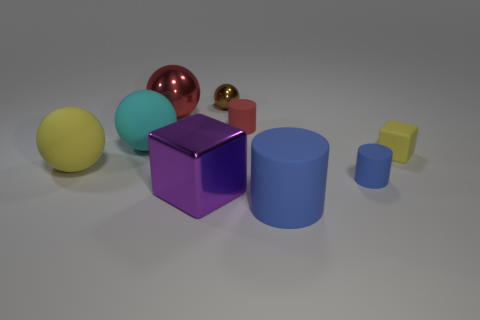Add 1 cyan cylinders. How many objects exist? 10 Subtract all tiny rubber cylinders. How many cylinders are left? 1 Subtract all brown spheres. How many spheres are left? 3 Subtract 1 blocks. How many blocks are left? 1 Subtract all green blocks. How many purple balls are left? 0 Subtract all balls. Subtract all red cylinders. How many objects are left? 4 Add 5 small red things. How many small red things are left? 6 Add 4 big cyan matte spheres. How many big cyan matte spheres exist? 5 Subtract 0 gray balls. How many objects are left? 9 Subtract all balls. How many objects are left? 5 